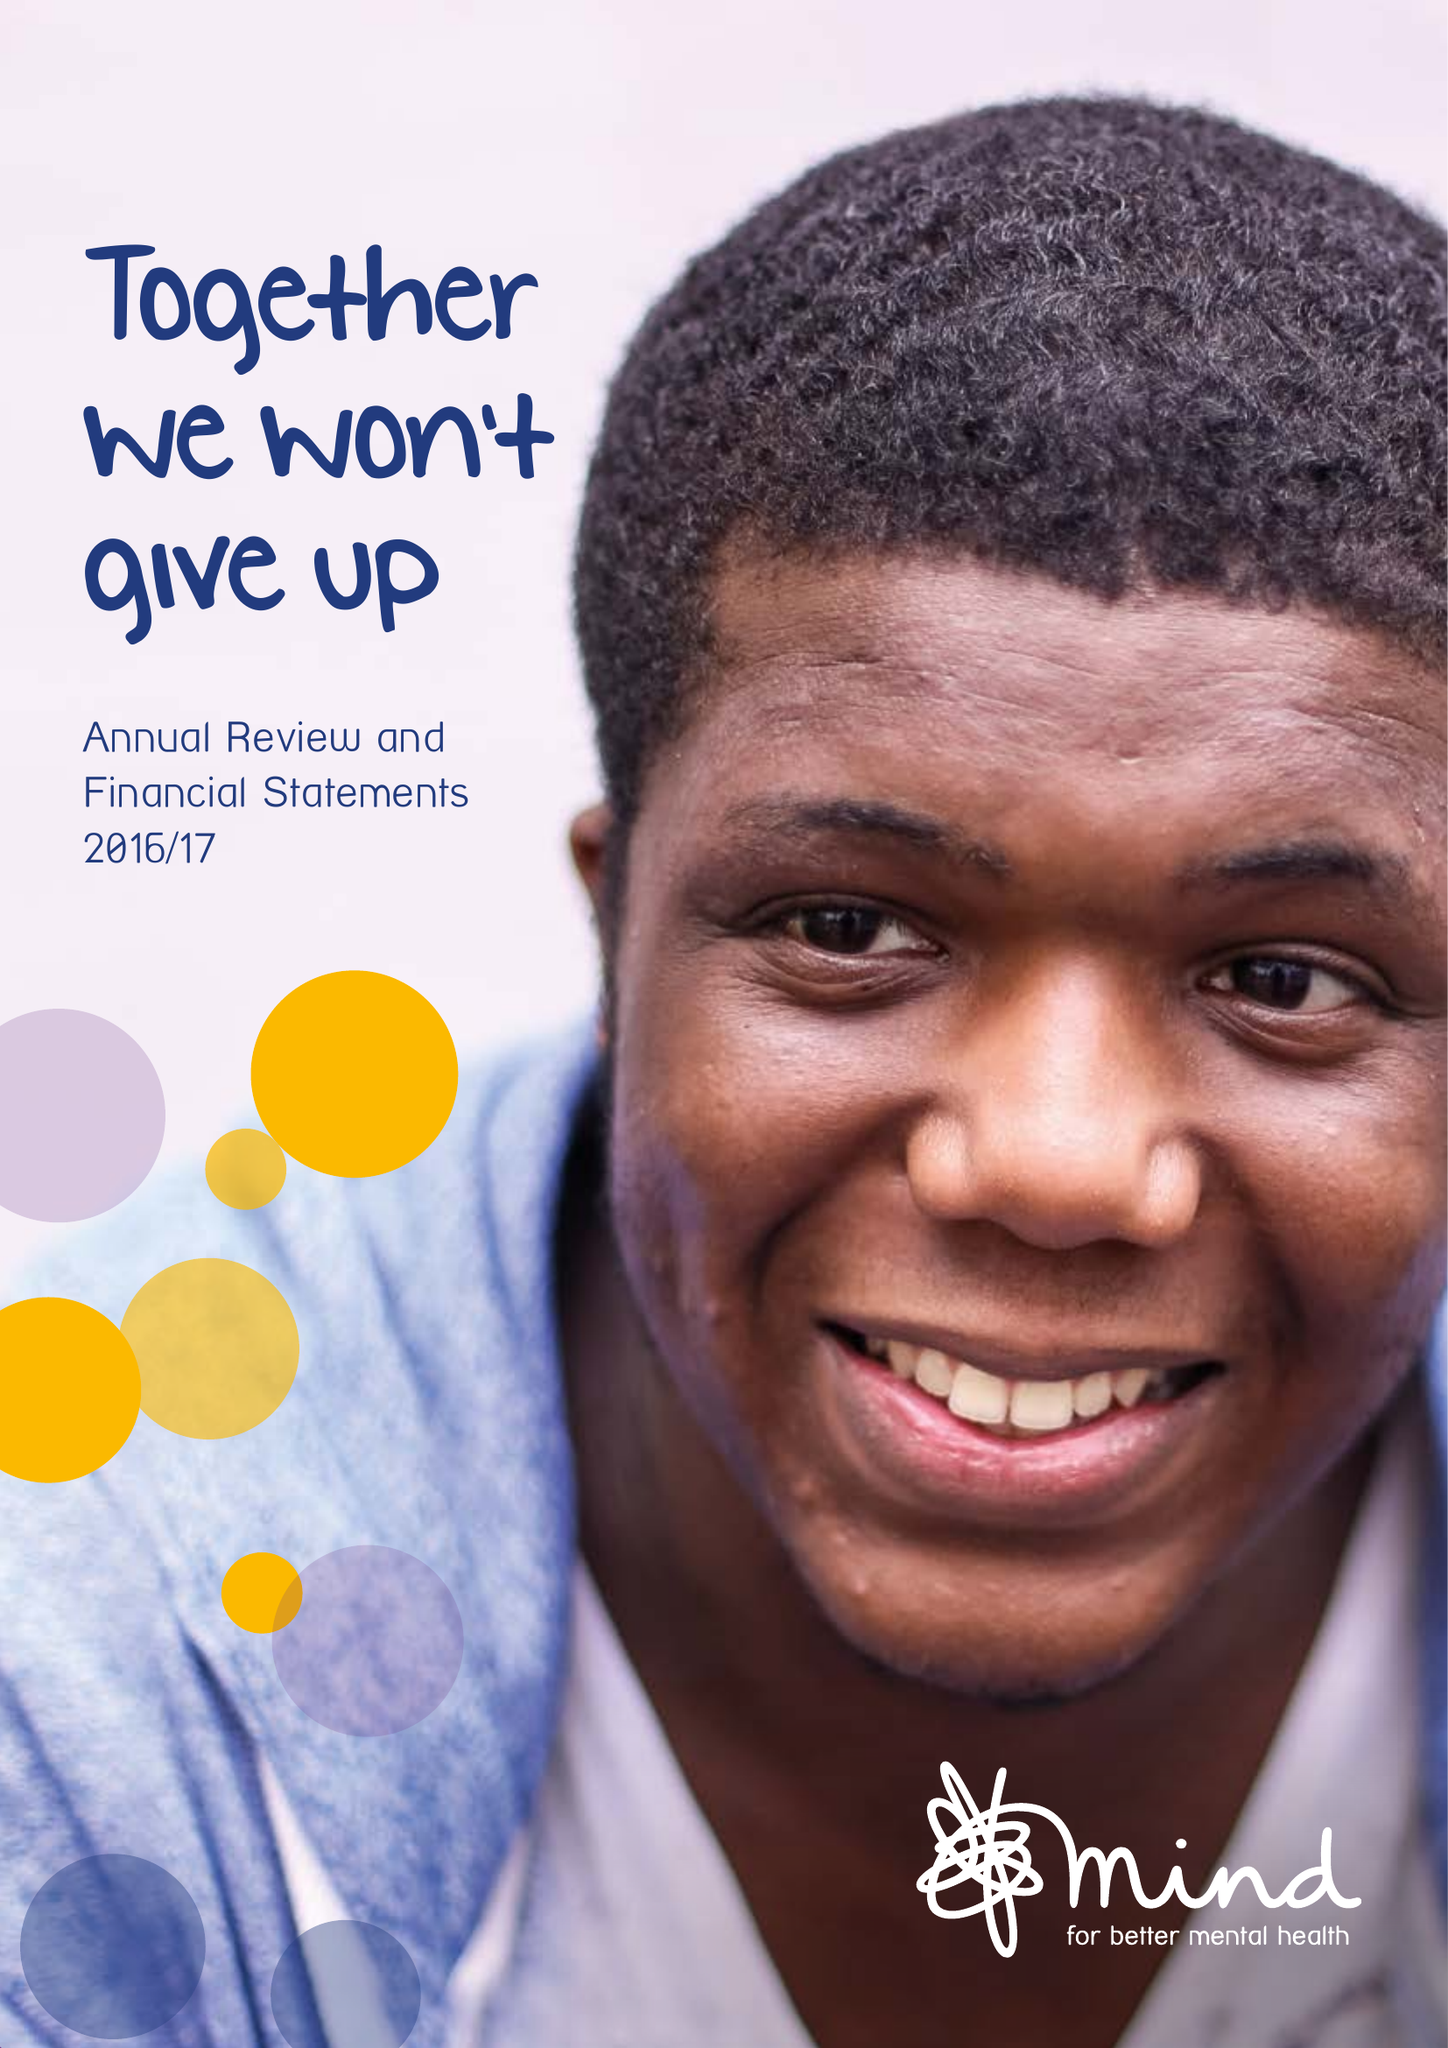What is the value for the charity_number?
Answer the question using a single word or phrase. 219830 